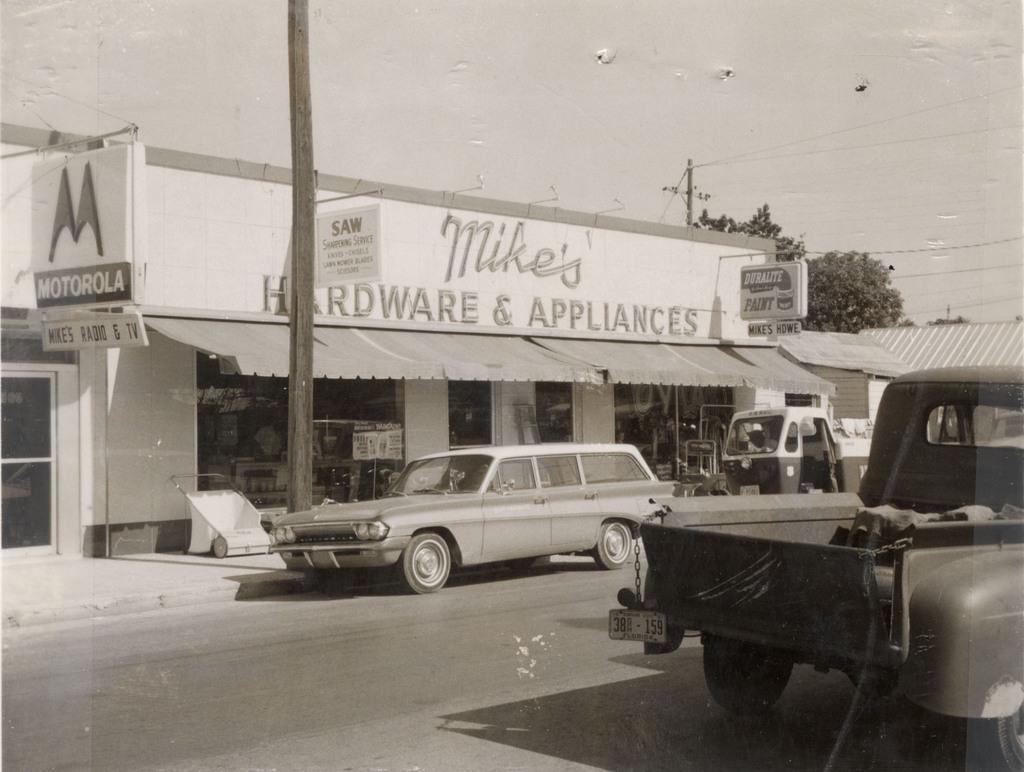Could you give a brief overview of what you see in this image? In this picture we can see vehicles on the road, platform, sunshade, banners, trees and in the background we can see the sky. 